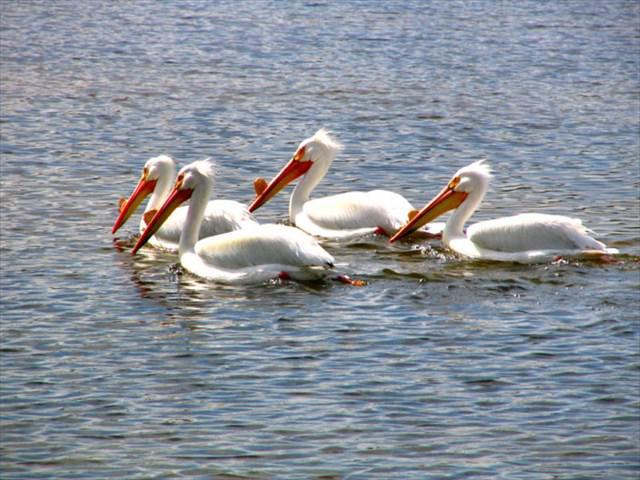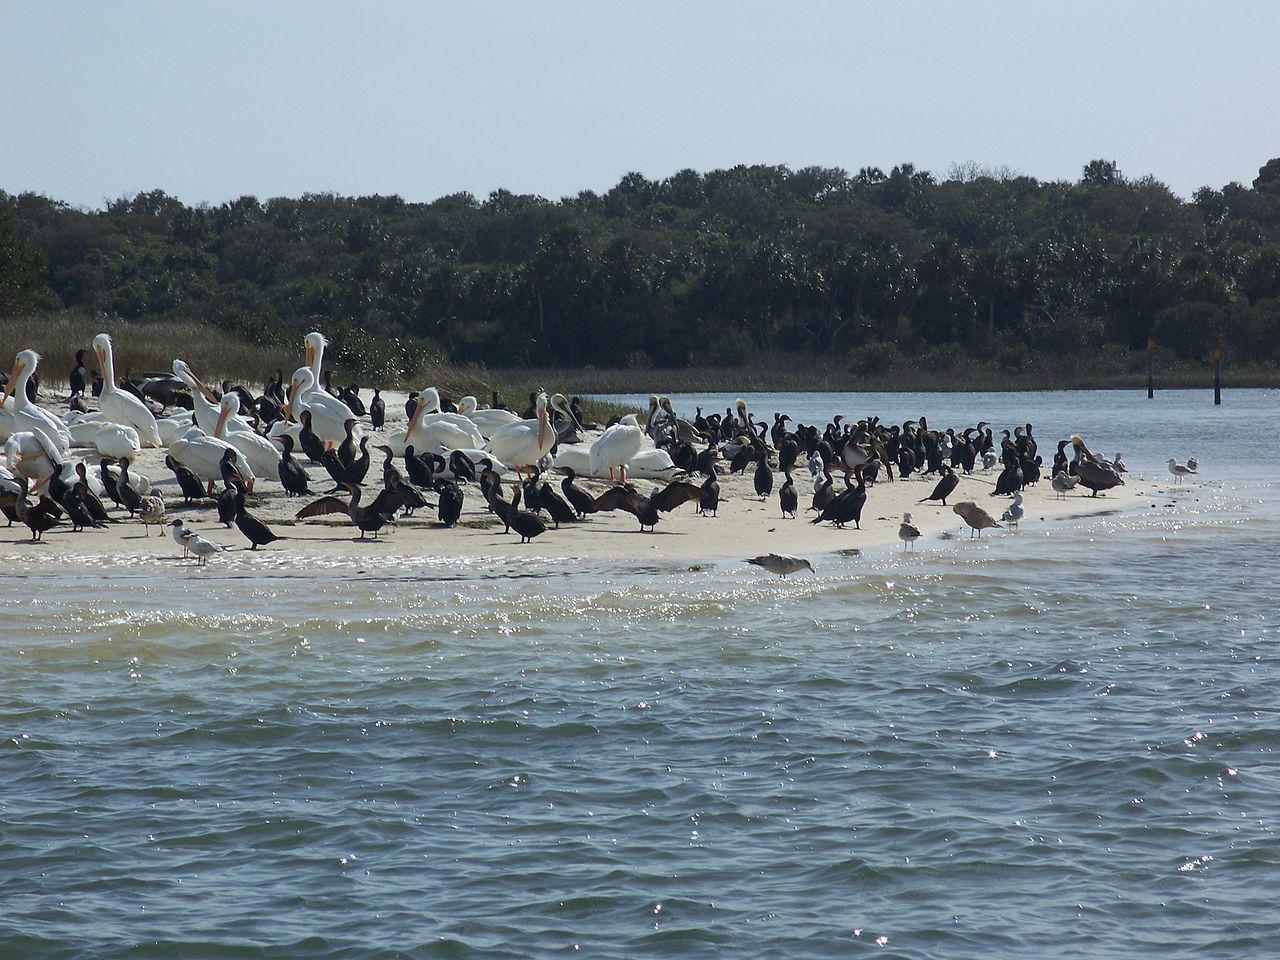The first image is the image on the left, the second image is the image on the right. Analyze the images presented: Is the assertion "An image shows exactly one pelican, which has a gaping mouth." valid? Answer yes or no. No. The first image is the image on the left, the second image is the image on the right. For the images shown, is this caption "One of the pelicans is opening its mouth wide." true? Answer yes or no. No. 